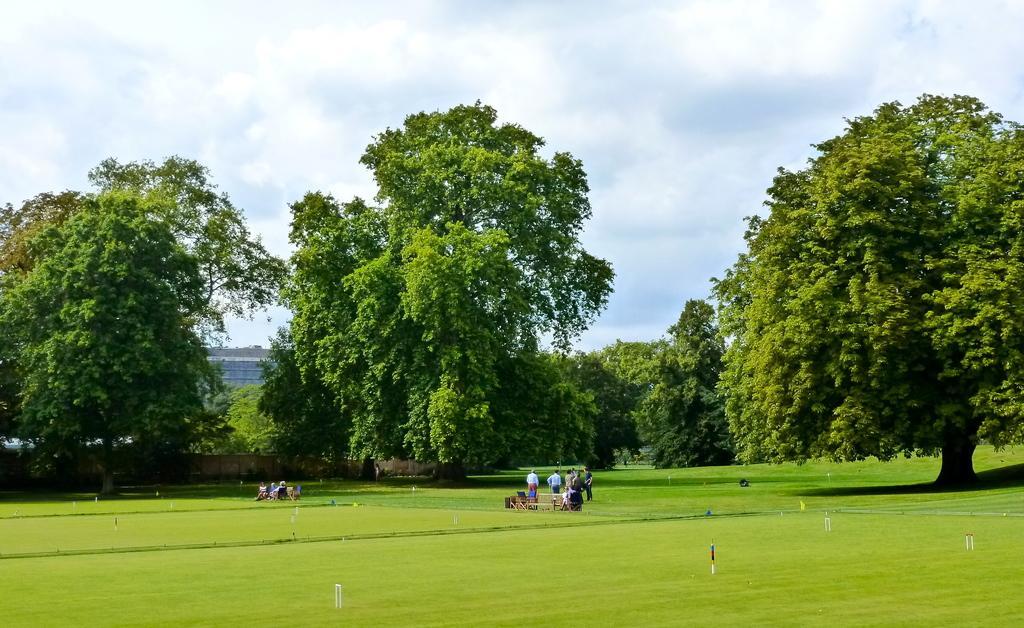How would you summarize this image in a sentence or two? In the image the land is totally covered with grass and in the middle there are few people standing and there are trees in the background all over the image and above its sky with clouds. 